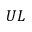Convert formula to latex. <formula><loc_0><loc_0><loc_500><loc_500>U L</formula> 